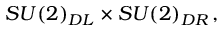Convert formula to latex. <formula><loc_0><loc_0><loc_500><loc_500>S U ( 2 ) _ { D L } \times S U ( 2 ) _ { D R } \, ,</formula> 